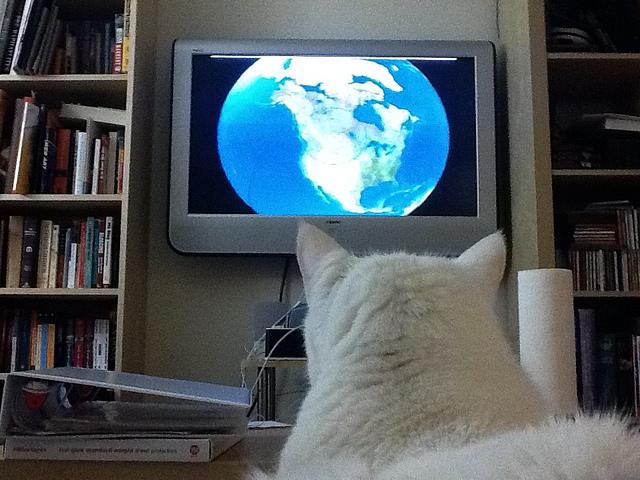What is the cat looking at?
Answer briefly. Tv. What are on the shelves?
Short answer required. Books. What color is the cat?
Write a very short answer. White. How many people are on the TV screen?
Short answer required. 0. 